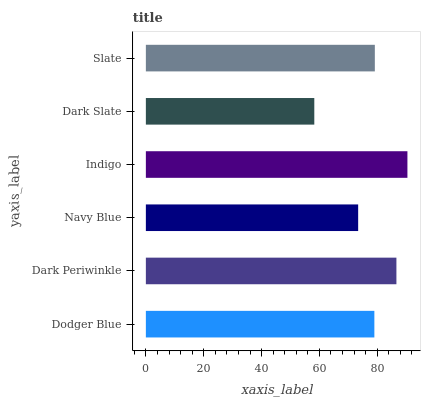Is Dark Slate the minimum?
Answer yes or no. Yes. Is Indigo the maximum?
Answer yes or no. Yes. Is Dark Periwinkle the minimum?
Answer yes or no. No. Is Dark Periwinkle the maximum?
Answer yes or no. No. Is Dark Periwinkle greater than Dodger Blue?
Answer yes or no. Yes. Is Dodger Blue less than Dark Periwinkle?
Answer yes or no. Yes. Is Dodger Blue greater than Dark Periwinkle?
Answer yes or no. No. Is Dark Periwinkle less than Dodger Blue?
Answer yes or no. No. Is Slate the high median?
Answer yes or no. Yes. Is Dodger Blue the low median?
Answer yes or no. Yes. Is Dark Slate the high median?
Answer yes or no. No. Is Dark Periwinkle the low median?
Answer yes or no. No. 